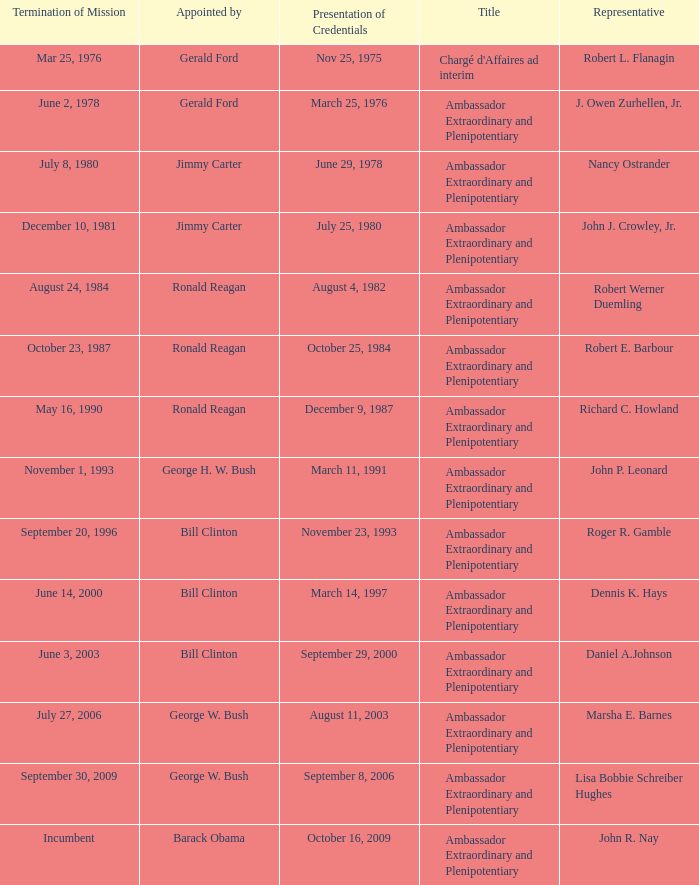Who appointed the representative that had a Presentation of Credentials on March 25, 1976? Gerald Ford. 